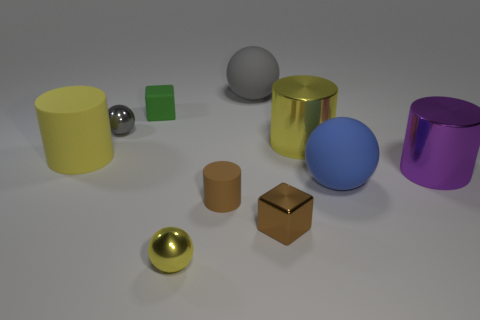There is a green object; what shape is it?
Keep it short and to the point. Cube. Is there any other thing that is the same size as the yellow ball?
Give a very brief answer. Yes. Is the number of small green blocks that are behind the blue object greater than the number of cyan rubber objects?
Offer a terse response. Yes. There is a large yellow object that is to the right of the gray sphere that is behind the gray object that is to the left of the big gray matte thing; what is its shape?
Make the answer very short. Cylinder. Does the matte cylinder in front of the blue matte object have the same size as the blue matte thing?
Provide a short and direct response. No. What shape is the matte object that is in front of the purple metal object and on the right side of the tiny brown cylinder?
Your answer should be very brief. Sphere. Do the large matte cylinder and the small ball that is in front of the small brown cylinder have the same color?
Provide a short and direct response. Yes. What color is the sphere on the right side of the big yellow object right of the tiny metallic sphere that is behind the big yellow shiny object?
Your answer should be compact. Blue. The other small object that is the same shape as the green thing is what color?
Keep it short and to the point. Brown. Are there an equal number of gray metal things in front of the tiny brown cylinder and metallic spheres?
Provide a succinct answer. No. 